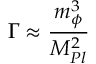<formula> <loc_0><loc_0><loc_500><loc_500>\Gamma \approx \frac { m _ { \phi } ^ { 3 } } { M _ { P l } ^ { 2 } }</formula> 